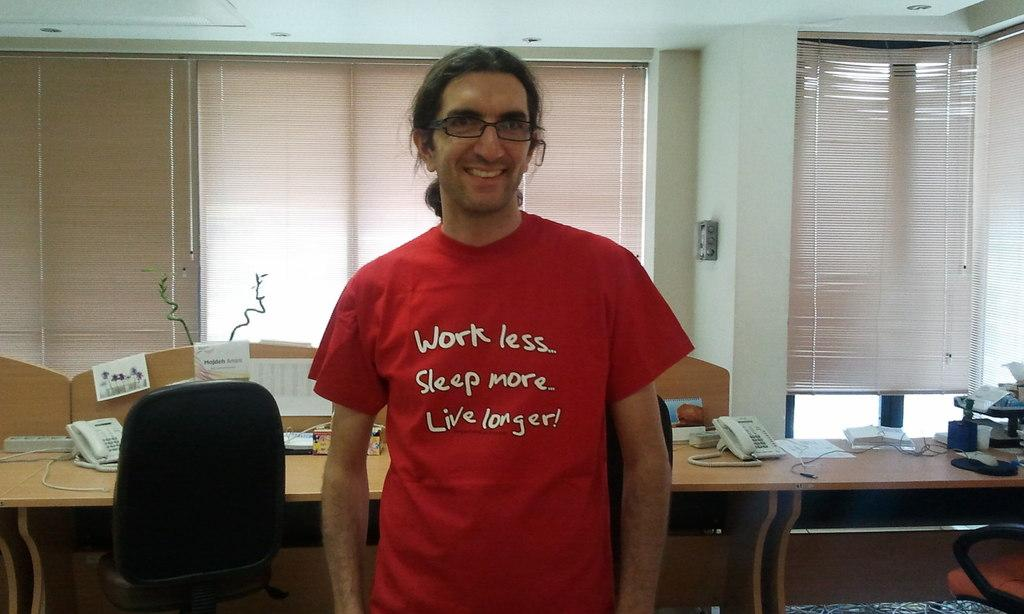What is the main subject of the image? There is a person in the image. What is the person wearing? The person is wearing a red t-shirt. What objects can be seen on the desks in the image? There are phones and papers on the desks in the image. What can be seen through the windows in the image? Windows are visible in the image, but the conversation does not specify what can be seen through them. What type of cherry is being used as a reward for the person in the image? There is no cherry or reward present in the image. Is the person in the image a lawyer? The facts provided do not mention the person's occupation, so it cannot be determined if they are a lawyer. 